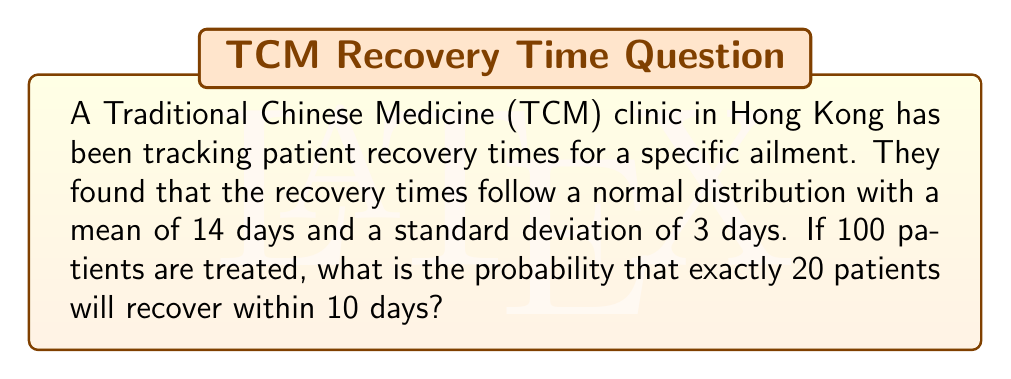Help me with this question. To solve this problem, we need to use the binomial distribution and the normal distribution. Let's break it down step by step:

1) First, we need to find the probability of a single patient recovering within 10 days. We can use the z-score formula:

   $z = \frac{x - \mu}{\sigma}$

   Where $x = 10$, $\mu = 14$, and $\sigma = 3$

   $z = \frac{10 - 14}{3} = -1.33$

2) Using a standard normal distribution table or calculator, we can find the probability for $z \leq -1.33$:

   $P(X \leq 10) = P(Z \leq -1.33) \approx 0.0918$

3) Now we know that for each patient, the probability of recovering within 10 days is about 0.0918.

4) We can use the binomial distribution to find the probability of exactly 20 out of 100 patients recovering within 10 days.

   The probability mass function for the binomial distribution is:

   $P(X = k) = \binom{n}{k} p^k (1-p)^{n-k}$

   Where $n = 100$, $k = 20$, and $p = 0.0918$

5) Plugging in these values:

   $P(X = 20) = \binom{100}{20} (0.0918)^{20} (1-0.0918)^{100-20}$

6) Calculating this (you may need a calculator):

   $P(X = 20) \approx 0.0000754$

Therefore, the probability of exactly 20 out of 100 patients recovering within 10 days is approximately 0.0000754 or about 0.00754%.
Answer: 0.0000754 